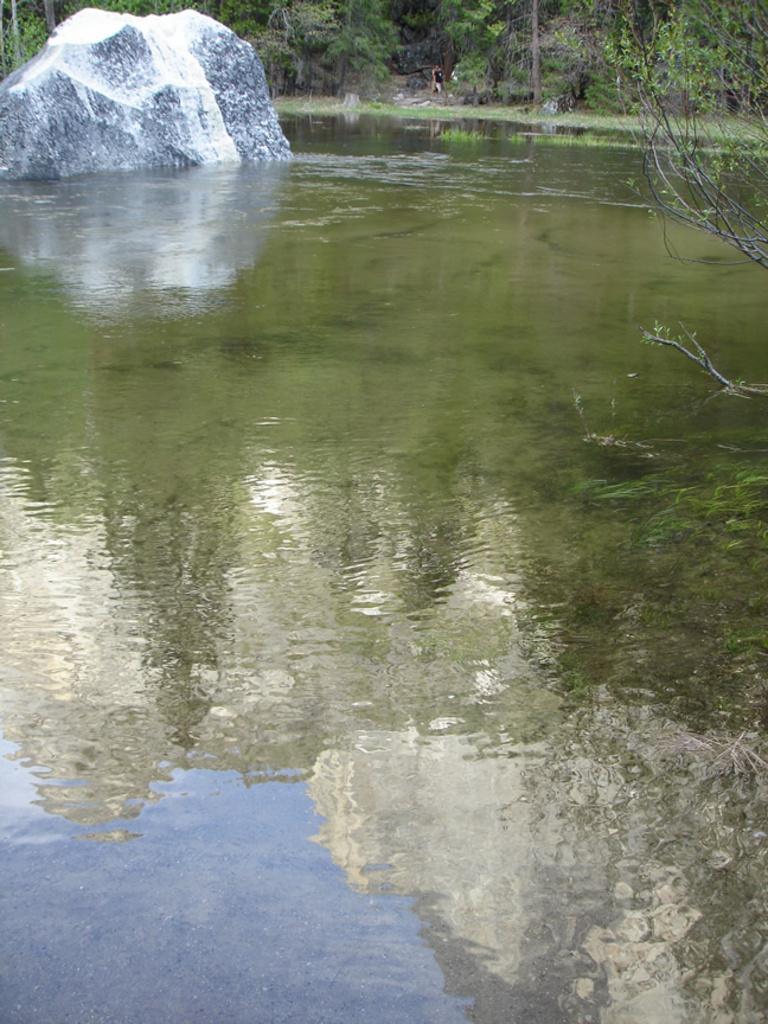Can you describe this image briefly? In this image we can see trees, rock and water. 